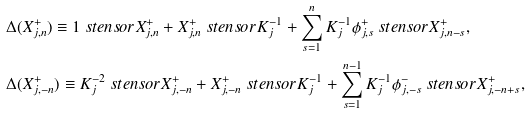Convert formula to latex. <formula><loc_0><loc_0><loc_500><loc_500>& \Delta ( X _ { j , n } ^ { + } ) \equiv 1 \ s t e n s o r X _ { j , n } ^ { + } + X _ { j , n } ^ { + } \ s t e n s o r K _ { j } ^ { - 1 } + \sum _ { s = 1 } ^ { n } K _ { j } ^ { - 1 } \phi _ { j , s } ^ { + } \ s t e n s o r X _ { j , n - s } ^ { + } , \\ & \Delta ( X _ { j , - n } ^ { + } ) \equiv K _ { j } ^ { - 2 } \ s t e n s o r X _ { j , - n } ^ { + } + X _ { j , - n } ^ { + } \ s t e n s o r K _ { j } ^ { - 1 } + \sum _ { s = 1 } ^ { n - 1 } K _ { j } ^ { - 1 } \phi _ { j , - s } ^ { - } \ s t e n s o r X _ { j , - n + s } ^ { + } ,</formula> 